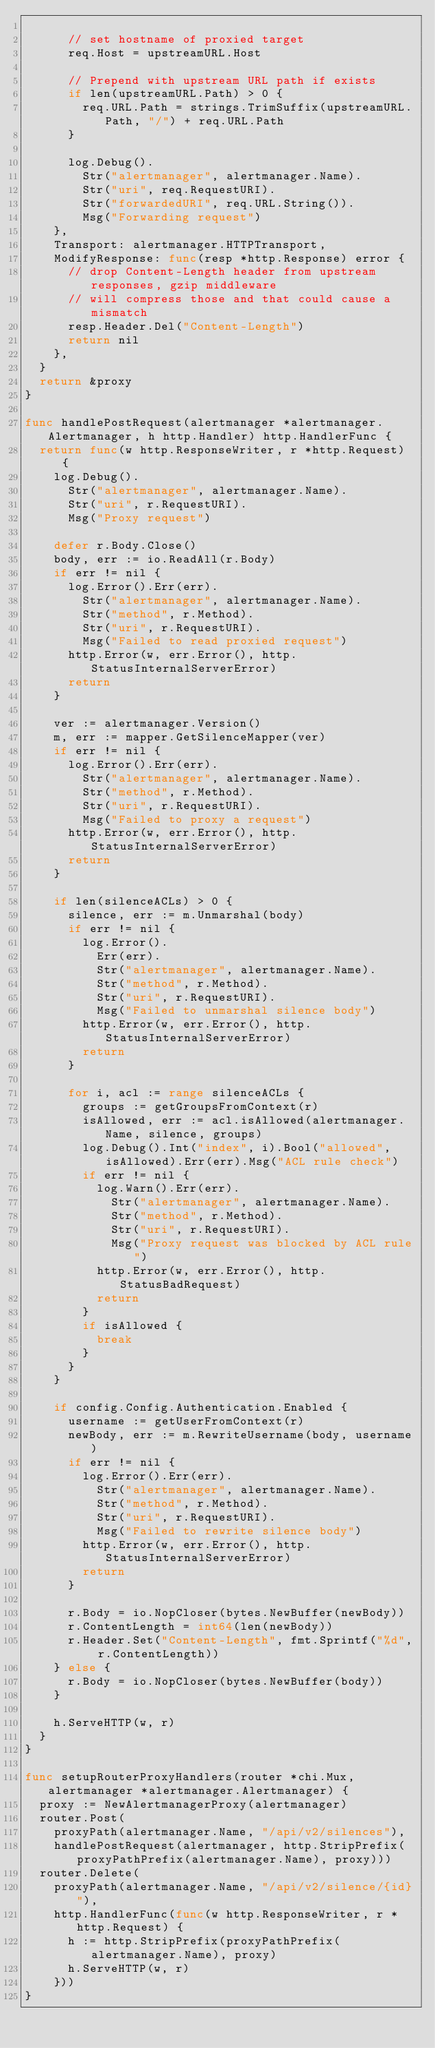<code> <loc_0><loc_0><loc_500><loc_500><_Go_>
			// set hostname of proxied target
			req.Host = upstreamURL.Host

			// Prepend with upstream URL path if exists
			if len(upstreamURL.Path) > 0 {
				req.URL.Path = strings.TrimSuffix(upstreamURL.Path, "/") + req.URL.Path
			}

			log.Debug().
				Str("alertmanager", alertmanager.Name).
				Str("uri", req.RequestURI).
				Str("forwardedURI", req.URL.String()).
				Msg("Forwarding request")
		},
		Transport: alertmanager.HTTPTransport,
		ModifyResponse: func(resp *http.Response) error {
			// drop Content-Length header from upstream responses, gzip middleware
			// will compress those and that could cause a mismatch
			resp.Header.Del("Content-Length")
			return nil
		},
	}
	return &proxy
}

func handlePostRequest(alertmanager *alertmanager.Alertmanager, h http.Handler) http.HandlerFunc {
	return func(w http.ResponseWriter, r *http.Request) {
		log.Debug().
			Str("alertmanager", alertmanager.Name).
			Str("uri", r.RequestURI).
			Msg("Proxy request")

		defer r.Body.Close()
		body, err := io.ReadAll(r.Body)
		if err != nil {
			log.Error().Err(err).
				Str("alertmanager", alertmanager.Name).
				Str("method", r.Method).
				Str("uri", r.RequestURI).
				Msg("Failed to read proxied request")
			http.Error(w, err.Error(), http.StatusInternalServerError)
			return
		}

		ver := alertmanager.Version()
		m, err := mapper.GetSilenceMapper(ver)
		if err != nil {
			log.Error().Err(err).
				Str("alertmanager", alertmanager.Name).
				Str("method", r.Method).
				Str("uri", r.RequestURI).
				Msg("Failed to proxy a request")
			http.Error(w, err.Error(), http.StatusInternalServerError)
			return
		}

		if len(silenceACLs) > 0 {
			silence, err := m.Unmarshal(body)
			if err != nil {
				log.Error().
					Err(err).
					Str("alertmanager", alertmanager.Name).
					Str("method", r.Method).
					Str("uri", r.RequestURI).
					Msg("Failed to unmarshal silence body")
				http.Error(w, err.Error(), http.StatusInternalServerError)
				return
			}

			for i, acl := range silenceACLs {
				groups := getGroupsFromContext(r)
				isAllowed, err := acl.isAllowed(alertmanager.Name, silence, groups)
				log.Debug().Int("index", i).Bool("allowed", isAllowed).Err(err).Msg("ACL rule check")
				if err != nil {
					log.Warn().Err(err).
						Str("alertmanager", alertmanager.Name).
						Str("method", r.Method).
						Str("uri", r.RequestURI).
						Msg("Proxy request was blocked by ACL rule")
					http.Error(w, err.Error(), http.StatusBadRequest)
					return
				}
				if isAllowed {
					break
				}
			}
		}

		if config.Config.Authentication.Enabled {
			username := getUserFromContext(r)
			newBody, err := m.RewriteUsername(body, username)
			if err != nil {
				log.Error().Err(err).
					Str("alertmanager", alertmanager.Name).
					Str("method", r.Method).
					Str("uri", r.RequestURI).
					Msg("Failed to rewrite silence body")
				http.Error(w, err.Error(), http.StatusInternalServerError)
				return
			}

			r.Body = io.NopCloser(bytes.NewBuffer(newBody))
			r.ContentLength = int64(len(newBody))
			r.Header.Set("Content-Length", fmt.Sprintf("%d", r.ContentLength))
		} else {
			r.Body = io.NopCloser(bytes.NewBuffer(body))
		}

		h.ServeHTTP(w, r)
	}
}

func setupRouterProxyHandlers(router *chi.Mux, alertmanager *alertmanager.Alertmanager) {
	proxy := NewAlertmanagerProxy(alertmanager)
	router.Post(
		proxyPath(alertmanager.Name, "/api/v2/silences"),
		handlePostRequest(alertmanager, http.StripPrefix(proxyPathPrefix(alertmanager.Name), proxy)))
	router.Delete(
		proxyPath(alertmanager.Name, "/api/v2/silence/{id}"),
		http.HandlerFunc(func(w http.ResponseWriter, r *http.Request) {
			h := http.StripPrefix(proxyPathPrefix(alertmanager.Name), proxy)
			h.ServeHTTP(w, r)
		}))
}
</code> 